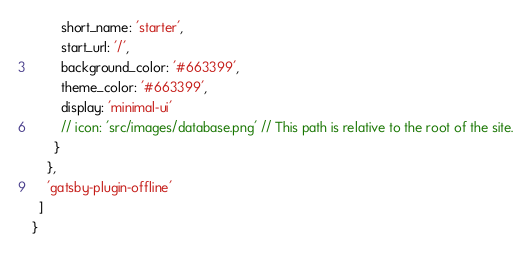<code> <loc_0><loc_0><loc_500><loc_500><_JavaScript_>        short_name: 'starter',
        start_url: '/',
        background_color: '#663399',
        theme_color: '#663399',
        display: 'minimal-ui'
        // icon: 'src/images/database.png' // This path is relative to the root of the site.
      }
    },
    'gatsby-plugin-offline'
  ]
}
</code> 